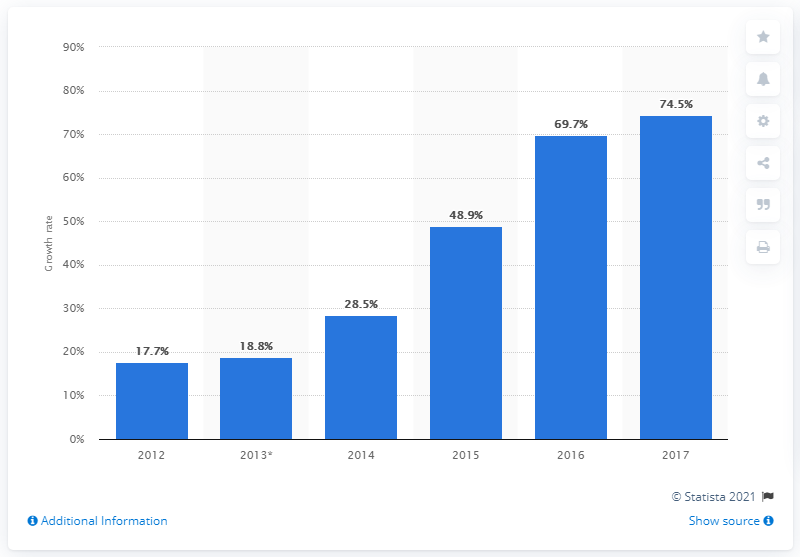Specify some key components in this picture. The expected growth rate of the mHealth market in China from 2015 to 2016 is projected to be 69.7%. 